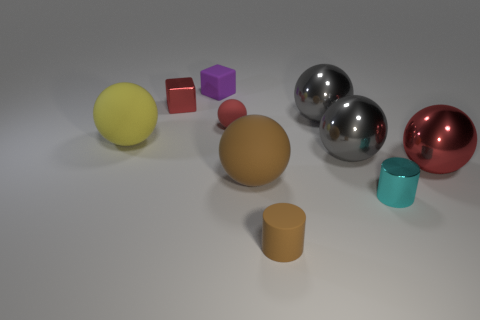Does the tiny sphere have the same color as the small metallic thing that is left of the brown rubber sphere?
Offer a very short reply. Yes. Is the color of the large rubber sphere that is in front of the large red sphere the same as the matte cylinder?
Make the answer very short. Yes. How many other things are there of the same color as the small matte ball?
Provide a succinct answer. 2. Does the small matte ball have the same color as the metal block?
Offer a terse response. Yes. There is a matte object that is both in front of the yellow matte object and behind the tiny brown object; what is its color?
Make the answer very short. Brown. What number of cyan cylinders are the same size as the purple object?
Your response must be concise. 1. What size is the sphere that is the same color as the small matte cylinder?
Your response must be concise. Large. There is a rubber thing that is in front of the big red thing and behind the cyan metal cylinder; what size is it?
Provide a short and direct response. Large. What number of red metal blocks are behind the red object to the right of the tiny red matte ball that is to the left of the brown sphere?
Provide a succinct answer. 1. Is there a large metallic object of the same color as the tiny ball?
Keep it short and to the point. Yes. 